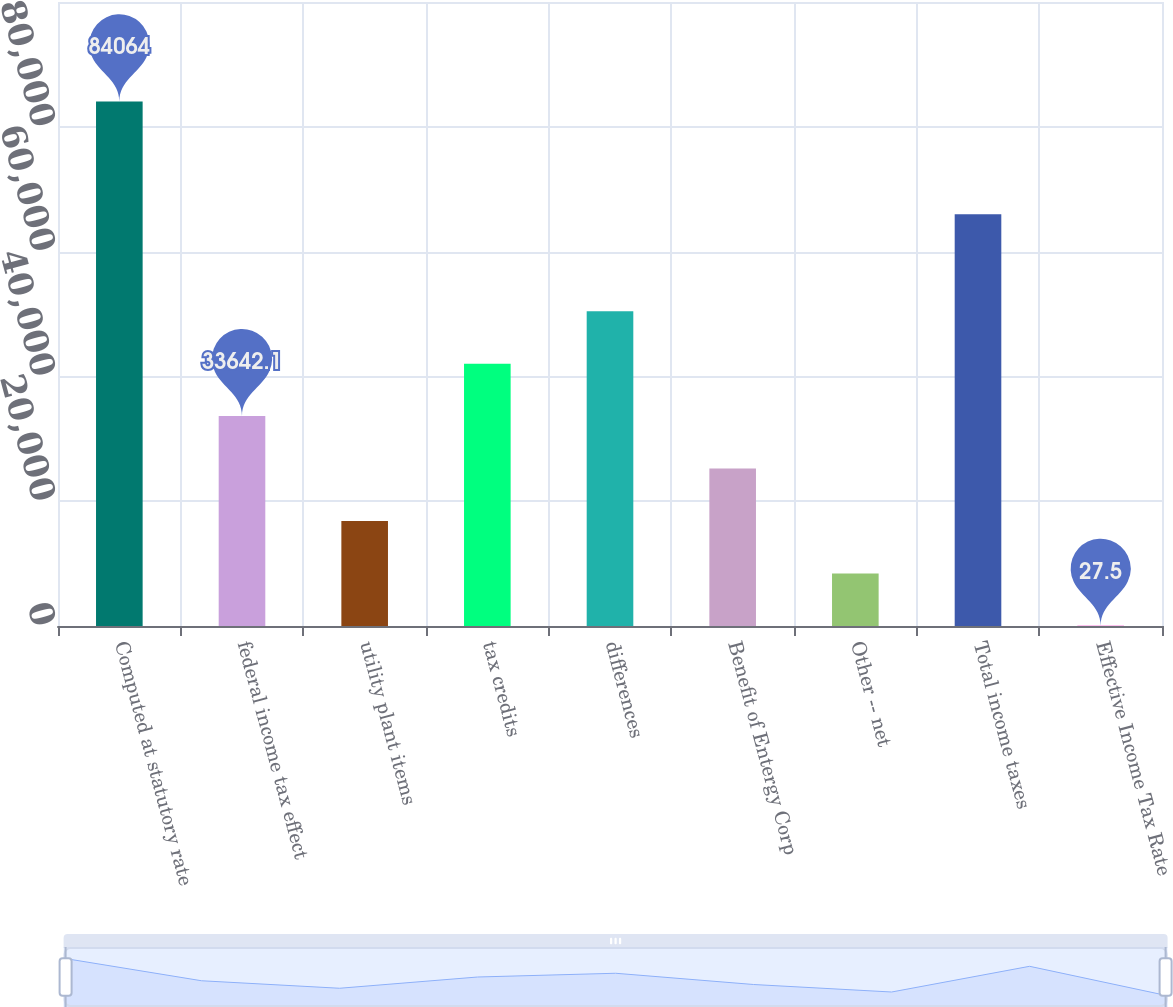Convert chart. <chart><loc_0><loc_0><loc_500><loc_500><bar_chart><fcel>Computed at statutory rate<fcel>federal income tax effect<fcel>utility plant items<fcel>tax credits<fcel>differences<fcel>Benefit of Entergy Corp<fcel>Other -- net<fcel>Total income taxes<fcel>Effective Income Tax Rate<nl><fcel>84064<fcel>33642.1<fcel>16834.8<fcel>42045.8<fcel>50449.4<fcel>25238.5<fcel>8431.15<fcel>65997<fcel>27.5<nl></chart> 